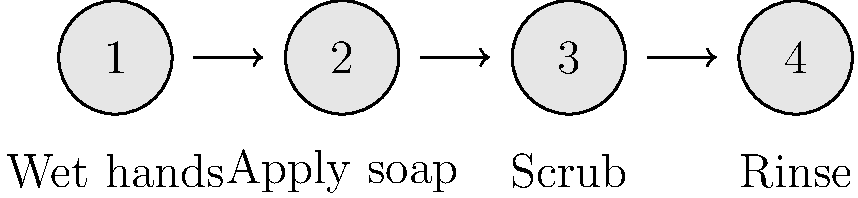Can you put these hand-washing steps in the correct order? Look at the cartoon hands and labels to help you! Let's go through the hand-washing steps one by one:

1. First, we need to wet our hands. This is shown by the first cartoon hand labeled "1" with "Wet hands" underneath.

2. After our hands are wet, we need to apply soap. This is represented by the second cartoon hand labeled "2" with "Apply soap" underneath.

3. Once we have soap on our hands, we need to scrub them thoroughly. This is shown by the third cartoon hand labeled "3" with "Scrub" underneath.

4. Finally, after scrubbing, we need to rinse off the soap. This is represented by the last cartoon hand labeled "4" with "Rinse" underneath.

The arrows between the cartoon hands show the correct order of these steps. By following this sequence, we ensure that our hands are properly cleaned and free from germs!
Answer: 1. Wet hands, 2. Apply soap, 3. Scrub, 4. Rinse 